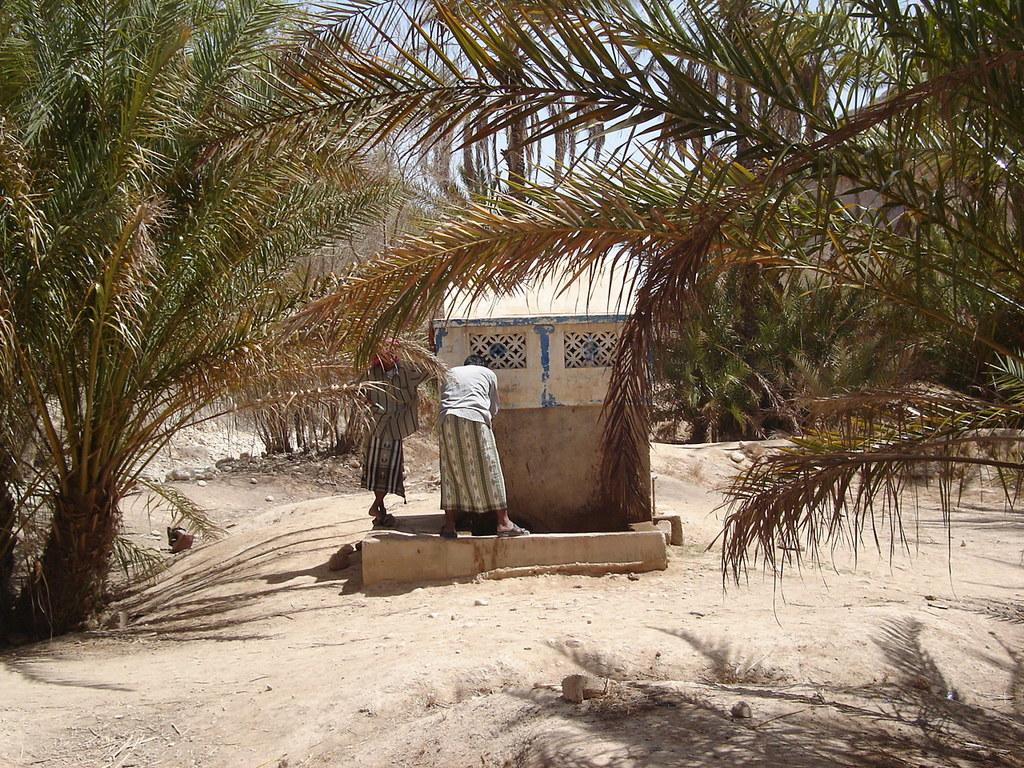How many people are present in the image? There are two people standing in the image. What can be seen in the background of the image? There are trees visible in the image. What is the condition of the ground in the image? The ground appears to be muddy. What type of glass is being used by the people in the image? There is no glass present in the image; it only shows two people standing and trees in the background. 